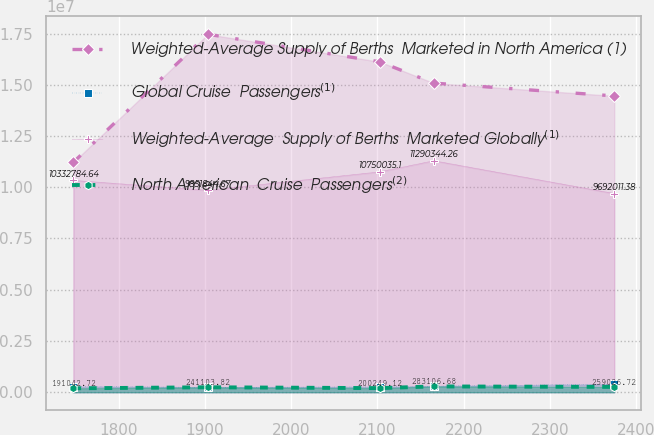Convert chart to OTSL. <chart><loc_0><loc_0><loc_500><loc_500><line_chart><ecel><fcel>Weighted-Average Supply of Berths  Marketed in North America (1)<fcel>Global Cruise  Passengers$^{(1)}$<fcel>Weighted-Average  Supply of Berths  Marketed Globally$^{(1)}$<fcel>North American  Cruise  Passengers$^{(2)}$<nl><fcel>1747.14<fcel>1.12198e+07<fcel>272801<fcel>1.03328e+07<fcel>191043<nl><fcel>1903.22<fcel>1.74629e+07<fcel>243238<fcel>9.85184e+06<fcel>241104<nl><fcel>2102.65<fcel>1.61208e+07<fcel>258019<fcel>1.075e+07<fcel>200249<nl><fcel>2165.4<fcel>1.508e+07<fcel>295712<fcel>1.12903e+07<fcel>283107<nl><fcel>2374.68<fcel>1.44557e+07<fcel>391054<fcel>9.69201e+06<fcel>259027<nl></chart> 